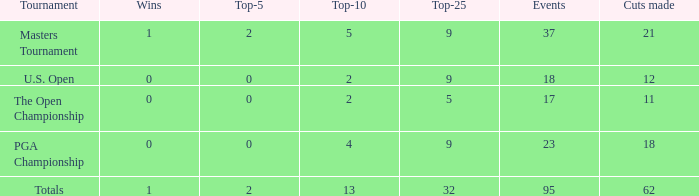What is the number of wins that is in the top 10 and larger than 13? None. 